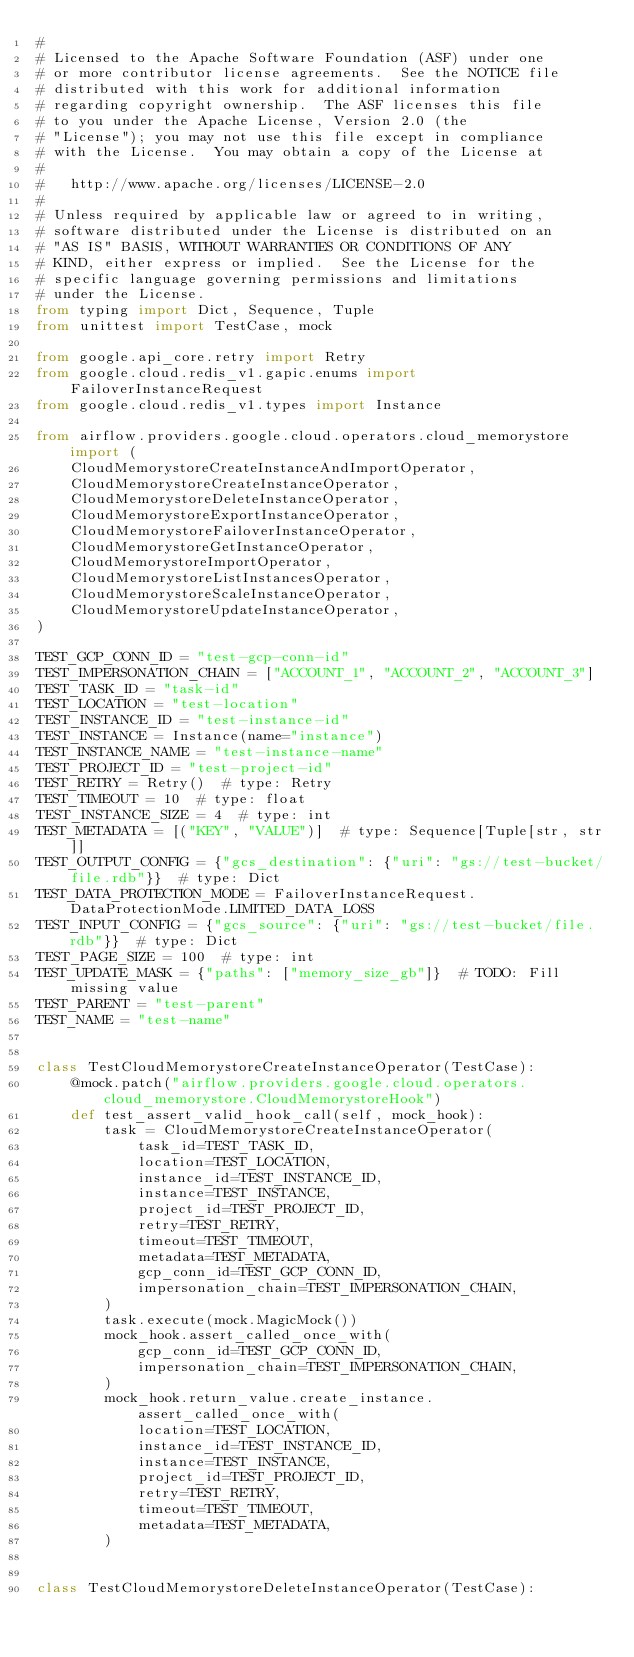<code> <loc_0><loc_0><loc_500><loc_500><_Python_>#
# Licensed to the Apache Software Foundation (ASF) under one
# or more contributor license agreements.  See the NOTICE file
# distributed with this work for additional information
# regarding copyright ownership.  The ASF licenses this file
# to you under the Apache License, Version 2.0 (the
# "License"); you may not use this file except in compliance
# with the License.  You may obtain a copy of the License at
#
#   http://www.apache.org/licenses/LICENSE-2.0
#
# Unless required by applicable law or agreed to in writing,
# software distributed under the License is distributed on an
# "AS IS" BASIS, WITHOUT WARRANTIES OR CONDITIONS OF ANY
# KIND, either express or implied.  See the License for the
# specific language governing permissions and limitations
# under the License.
from typing import Dict, Sequence, Tuple
from unittest import TestCase, mock

from google.api_core.retry import Retry
from google.cloud.redis_v1.gapic.enums import FailoverInstanceRequest
from google.cloud.redis_v1.types import Instance

from airflow.providers.google.cloud.operators.cloud_memorystore import (
    CloudMemorystoreCreateInstanceAndImportOperator,
    CloudMemorystoreCreateInstanceOperator,
    CloudMemorystoreDeleteInstanceOperator,
    CloudMemorystoreExportInstanceOperator,
    CloudMemorystoreFailoverInstanceOperator,
    CloudMemorystoreGetInstanceOperator,
    CloudMemorystoreImportOperator,
    CloudMemorystoreListInstancesOperator,
    CloudMemorystoreScaleInstanceOperator,
    CloudMemorystoreUpdateInstanceOperator,
)

TEST_GCP_CONN_ID = "test-gcp-conn-id"
TEST_IMPERSONATION_CHAIN = ["ACCOUNT_1", "ACCOUNT_2", "ACCOUNT_3"]
TEST_TASK_ID = "task-id"
TEST_LOCATION = "test-location"
TEST_INSTANCE_ID = "test-instance-id"
TEST_INSTANCE = Instance(name="instance")
TEST_INSTANCE_NAME = "test-instance-name"
TEST_PROJECT_ID = "test-project-id"
TEST_RETRY = Retry()  # type: Retry
TEST_TIMEOUT = 10  # type: float
TEST_INSTANCE_SIZE = 4  # type: int
TEST_METADATA = [("KEY", "VALUE")]  # type: Sequence[Tuple[str, str]]
TEST_OUTPUT_CONFIG = {"gcs_destination": {"uri": "gs://test-bucket/file.rdb"}}  # type: Dict
TEST_DATA_PROTECTION_MODE = FailoverInstanceRequest.DataProtectionMode.LIMITED_DATA_LOSS
TEST_INPUT_CONFIG = {"gcs_source": {"uri": "gs://test-bucket/file.rdb"}}  # type: Dict
TEST_PAGE_SIZE = 100  # type: int
TEST_UPDATE_MASK = {"paths": ["memory_size_gb"]}  # TODO: Fill missing value
TEST_PARENT = "test-parent"
TEST_NAME = "test-name"


class TestCloudMemorystoreCreateInstanceOperator(TestCase):
    @mock.patch("airflow.providers.google.cloud.operators.cloud_memorystore.CloudMemorystoreHook")
    def test_assert_valid_hook_call(self, mock_hook):
        task = CloudMemorystoreCreateInstanceOperator(
            task_id=TEST_TASK_ID,
            location=TEST_LOCATION,
            instance_id=TEST_INSTANCE_ID,
            instance=TEST_INSTANCE,
            project_id=TEST_PROJECT_ID,
            retry=TEST_RETRY,
            timeout=TEST_TIMEOUT,
            metadata=TEST_METADATA,
            gcp_conn_id=TEST_GCP_CONN_ID,
            impersonation_chain=TEST_IMPERSONATION_CHAIN,
        )
        task.execute(mock.MagicMock())
        mock_hook.assert_called_once_with(
            gcp_conn_id=TEST_GCP_CONN_ID,
            impersonation_chain=TEST_IMPERSONATION_CHAIN,
        )
        mock_hook.return_value.create_instance.assert_called_once_with(
            location=TEST_LOCATION,
            instance_id=TEST_INSTANCE_ID,
            instance=TEST_INSTANCE,
            project_id=TEST_PROJECT_ID,
            retry=TEST_RETRY,
            timeout=TEST_TIMEOUT,
            metadata=TEST_METADATA,
        )


class TestCloudMemorystoreDeleteInstanceOperator(TestCase):</code> 